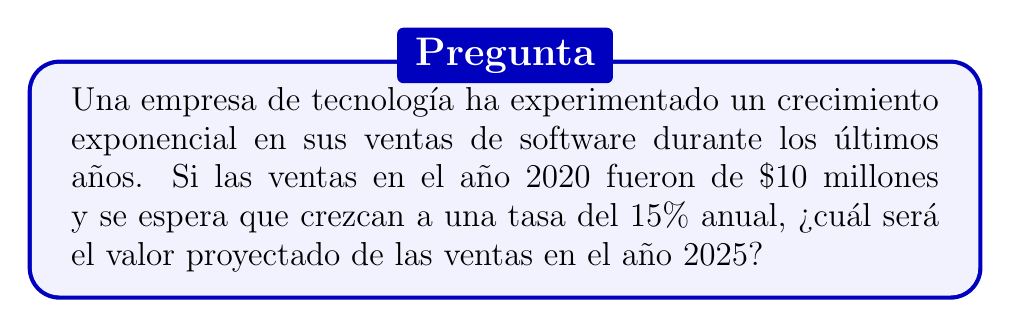Give your solution to this math problem. Para resolver este problema, utilizaremos el modelo de crecimiento exponencial:

$A = P(1 + r)^t$

Donde:
$A$ = Valor final (ventas en 2025)
$P$ = Valor inicial (ventas en 2020) = $10 millones
$r$ = Tasa de crecimiento anual = 15% = 0.15
$t$ = Tiempo transcurrido = 5 años (de 2020 a 2025)

Sustituyendo los valores en la fórmula:

$A = 10(1 + 0.15)^5$

Resolvemos paso a paso:

1) $A = 10(1.15)^5$
2) $A = 10(2.0113689)$
3) $A = 20.113689$

Redondeando a dos decimales:

$A ≈ 20.11$ millones de dólares
Answer: $20.11 millones 